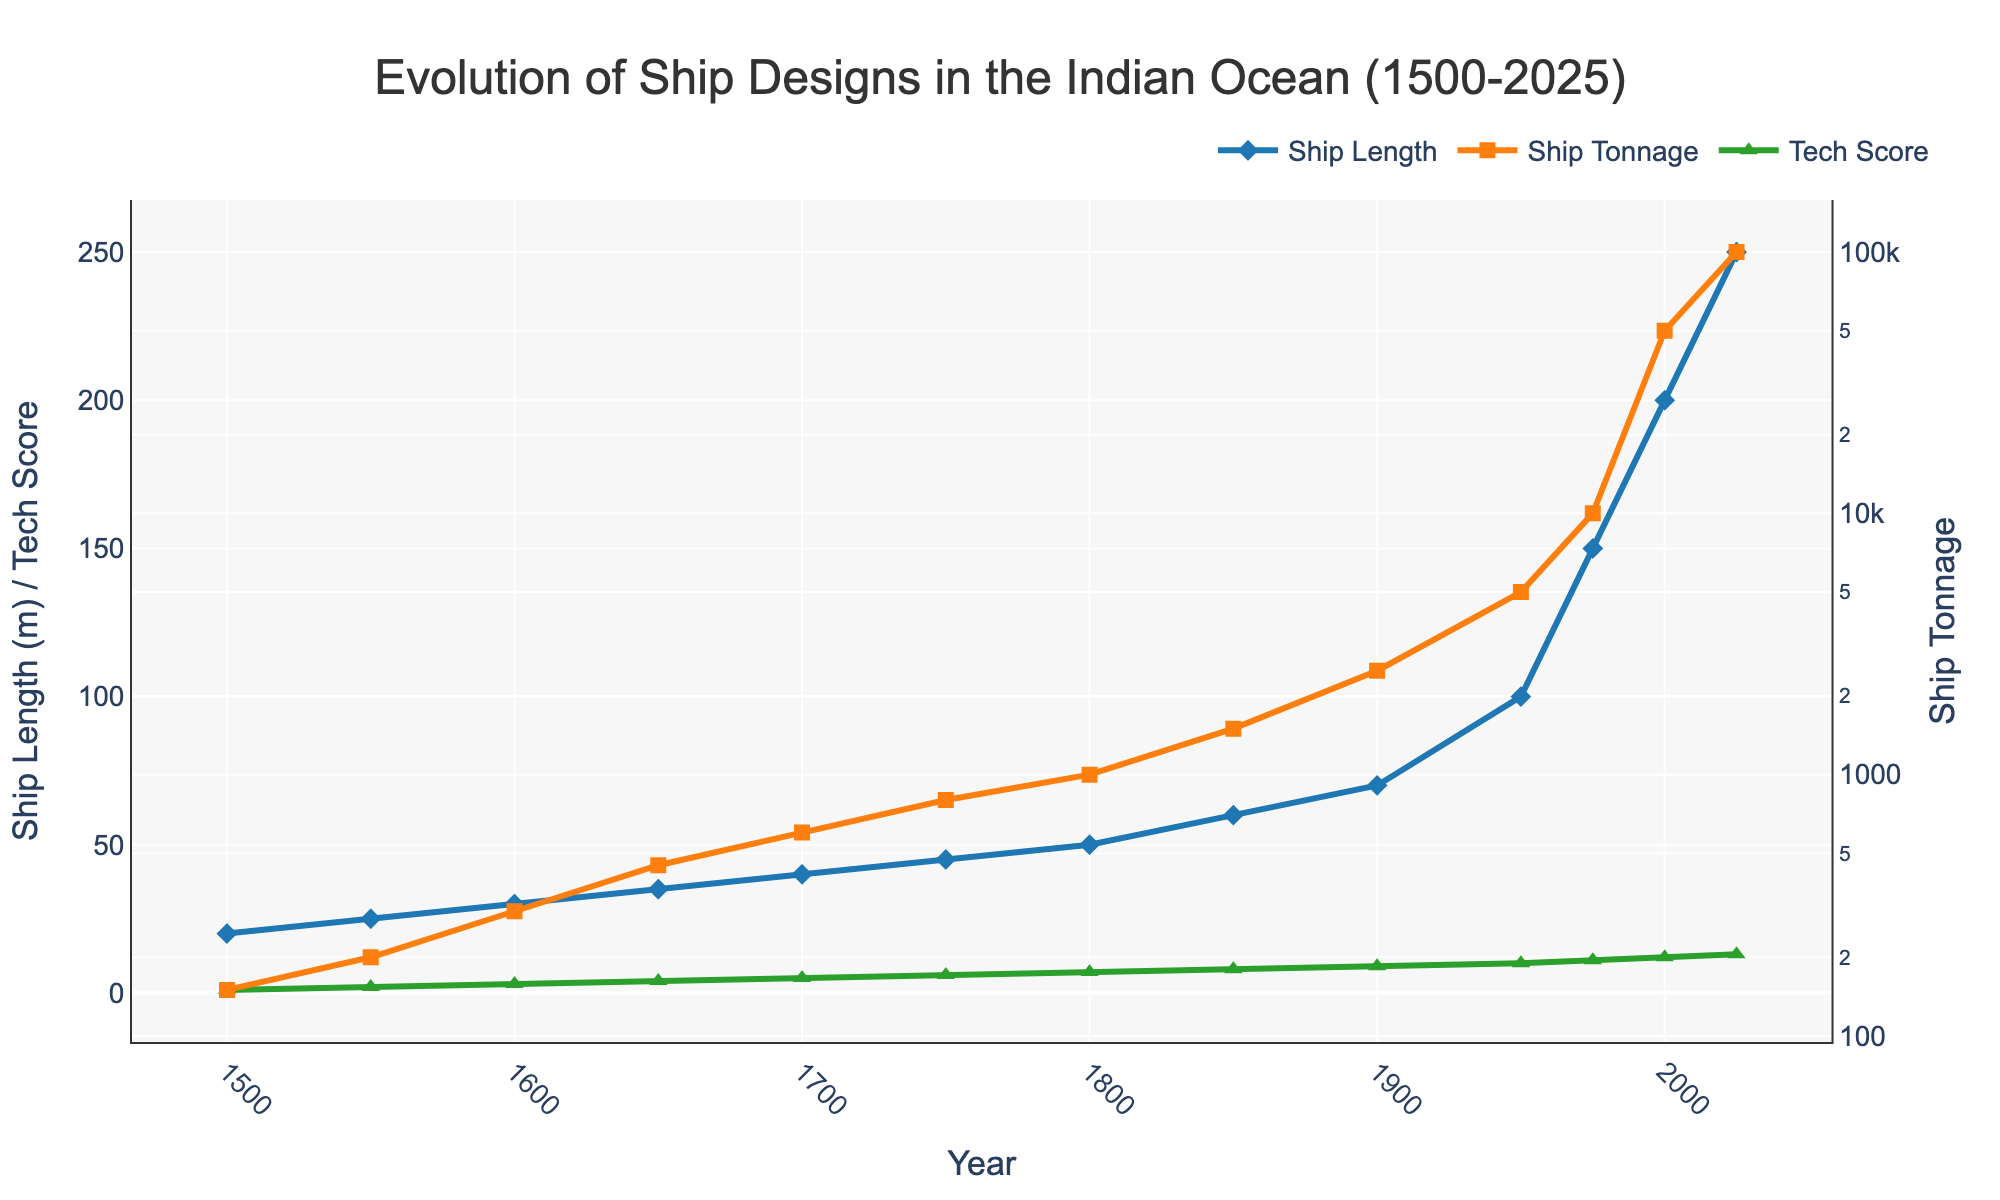What trend can be observed in the average ship length from 1500 to 2025? The line representing the average ship length shows a consistent increase over time, with the most significant jumps occurring between 1950 and 1975, and from 2000 to 2025. This indicates a steady growth in the size of ships.
Answer: Consistently increasing Which year saw the greatest increase in average ship length compared to the previous recorded year? The vertical distance between the markers for each year is greatest between 1975 and 2000, where the average ship length goes from 150 meters to 200 meters, showing a 50-meter increase.
Answer: 2000 What was the average ship tonnage around the year 1700? Locate the orange square marker on the year 1700 along the secondary y-axis which uses a logarithmic scale. The marker indicates around 600 tons.
Answer: 600 tons How does the technological advancements score correlate with ship length over time? Both the ship length and technological advancements score increase simultaneously over time. The two metrics appear to move in parallel, suggesting a strong positive correlation.
Answer: Positively correlated By how much did the average ship tonnage increase between 1600 and 1850? Using the secondary y-axis for tonnage, the ship tonnage in 1600 is approximately 300 tons, and in 1850 it is about 1500 tons. Subtract the former from the latter (1500 - 300).
Answer: 1200 tons Comparing the trends, which metric saw the most dramatic change after 1950: average ship length or average ship tonnage? Post-1950, the green triangle markers for technological advancements show a moderate increase, while the blue diamond markers for the average ship length and the orange square markers for average ship tonnage show significant changes. The tonnage metric, in particular, shows a dramatic increase on the logarithmic scale.
Answer: Ship tonnage What year did the technological advancements score reach 10? Refer to the green triangle markers on the primary y-axis marked 'Tech Score'. The score reaches 10 in the year 1950.
Answer: 1950 When did the average ship length reach at least 100 meters? Follow the blue diamond markers along the primary y-axis representing ship length. The length reaches 100 meters at the year 1950.
Answer: 1950 In which period did the ship length and tonnage both double in value? From 1900 to 1950, ship length increased from 70 to 100 meters and tonnage increased from 2500 to 5000. Both metrics approximately doubled in this period.
Answer: 1900 to 1950 How much higher is the technological advancements score in 2025 compared to 1750? The score in 2025 is 13, and in 1750 it is 6. Subtract the latter from the former (13 - 6).
Answer: 7 